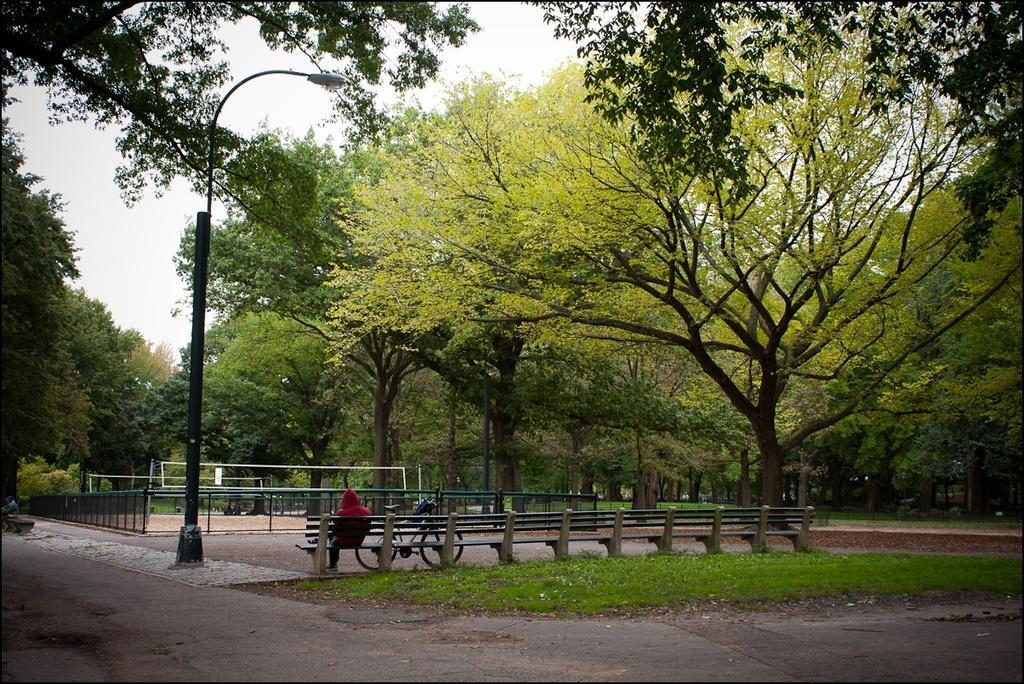Please provide a concise description of this image. This picture is clicked outside. In the center we can see a bicycle and a person sitting on the bench and we can see the green grass, lamppost, trees metal rods and on the left corner we can see a person like thing and we can see some other objects. In the background we can see the sky. 